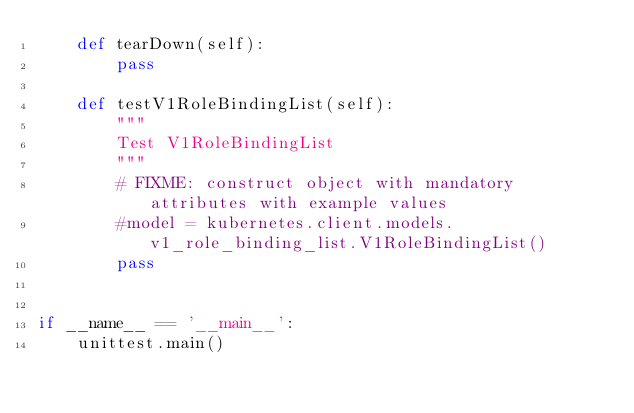Convert code to text. <code><loc_0><loc_0><loc_500><loc_500><_Python_>    def tearDown(self):
        pass

    def testV1RoleBindingList(self):
        """
        Test V1RoleBindingList
        """
        # FIXME: construct object with mandatory attributes with example values
        #model = kubernetes.client.models.v1_role_binding_list.V1RoleBindingList()
        pass


if __name__ == '__main__':
    unittest.main()
</code> 